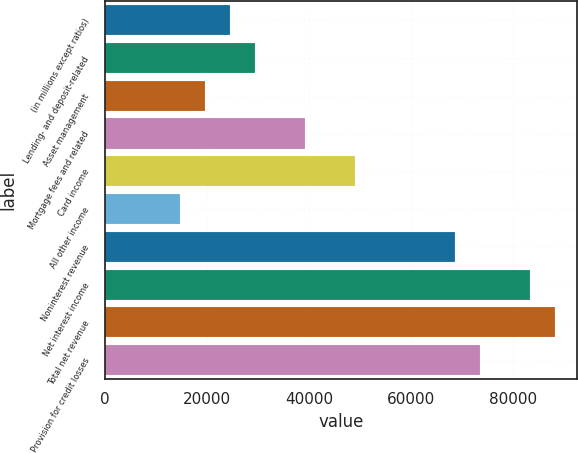Convert chart to OTSL. <chart><loc_0><loc_0><loc_500><loc_500><bar_chart><fcel>(in millions except ratios)<fcel>Lending- and deposit-related<fcel>Asset management<fcel>Mortgage fees and related<fcel>Card income<fcel>All other income<fcel>Noninterest revenue<fcel>Net interest income<fcel>Total net revenue<fcel>Provision for credit losses<nl><fcel>24469<fcel>29360.6<fcel>19577.4<fcel>39143.8<fcel>48927<fcel>14685.8<fcel>68493.4<fcel>83168.2<fcel>88059.8<fcel>73385<nl></chart> 